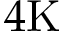<formula> <loc_0><loc_0><loc_500><loc_500>4 K</formula> 